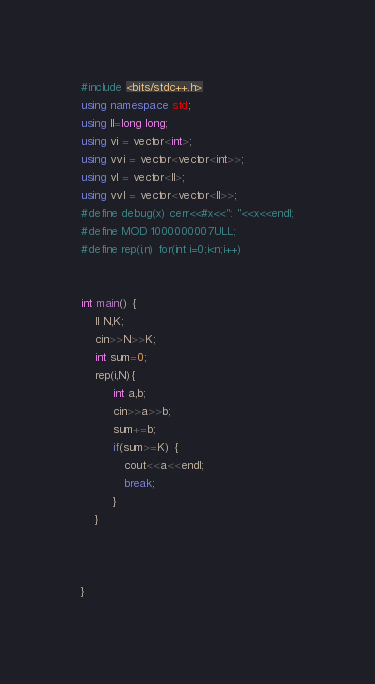<code> <loc_0><loc_0><loc_500><loc_500><_C++_>#include <bits/stdc++.h>
using namespace std;
using ll=long long;
using vi = vector<int>;
using vvi = vector<vector<int>>;
using vl = vector<ll>;
using vvl = vector<vector<ll>>;
#define debug(x) cerr<<#x<<": "<<x<<endl;
#define MOD 1000000007ULL;
#define rep(i,n) for(int i=0;i<n;i++)


int main() {
	ll N,K;
  	cin>>N>>K;
  	int sum=0;
  	rep(i,N){
     	 int a,b;
      	 cin>>a>>b;
      	 sum+=b;
      	 if(sum>=K) {
           	cout<<a<<endl;
            break;
         }
    }
    
  	
  	
}</code> 